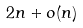Convert formula to latex. <formula><loc_0><loc_0><loc_500><loc_500>2 n + o ( n )</formula> 